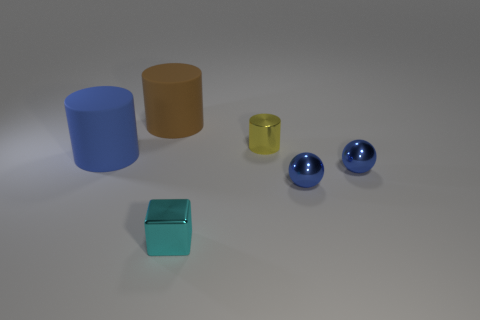Is there anything else that is the same shape as the small cyan metal object?
Your response must be concise. No. There is a cylinder in front of the yellow shiny cylinder; what material is it?
Your answer should be very brief. Rubber. Is there a thing of the same color as the tiny metal cylinder?
Provide a succinct answer. No. The other rubber object that is the same size as the brown thing is what color?
Offer a terse response. Blue. How many large things are rubber cylinders or blue spheres?
Provide a short and direct response. 2. Are there an equal number of rubber cylinders that are behind the metal cube and big blue rubber things to the right of the tiny cylinder?
Make the answer very short. No. How many purple metallic cubes have the same size as the yellow cylinder?
Give a very brief answer. 0. What number of yellow objects are either balls or small things?
Offer a very short reply. 1. Are there an equal number of brown rubber things that are left of the brown cylinder and big gray metallic cylinders?
Provide a short and direct response. Yes. There is a matte cylinder to the right of the large blue rubber cylinder; how big is it?
Keep it short and to the point. Large. 